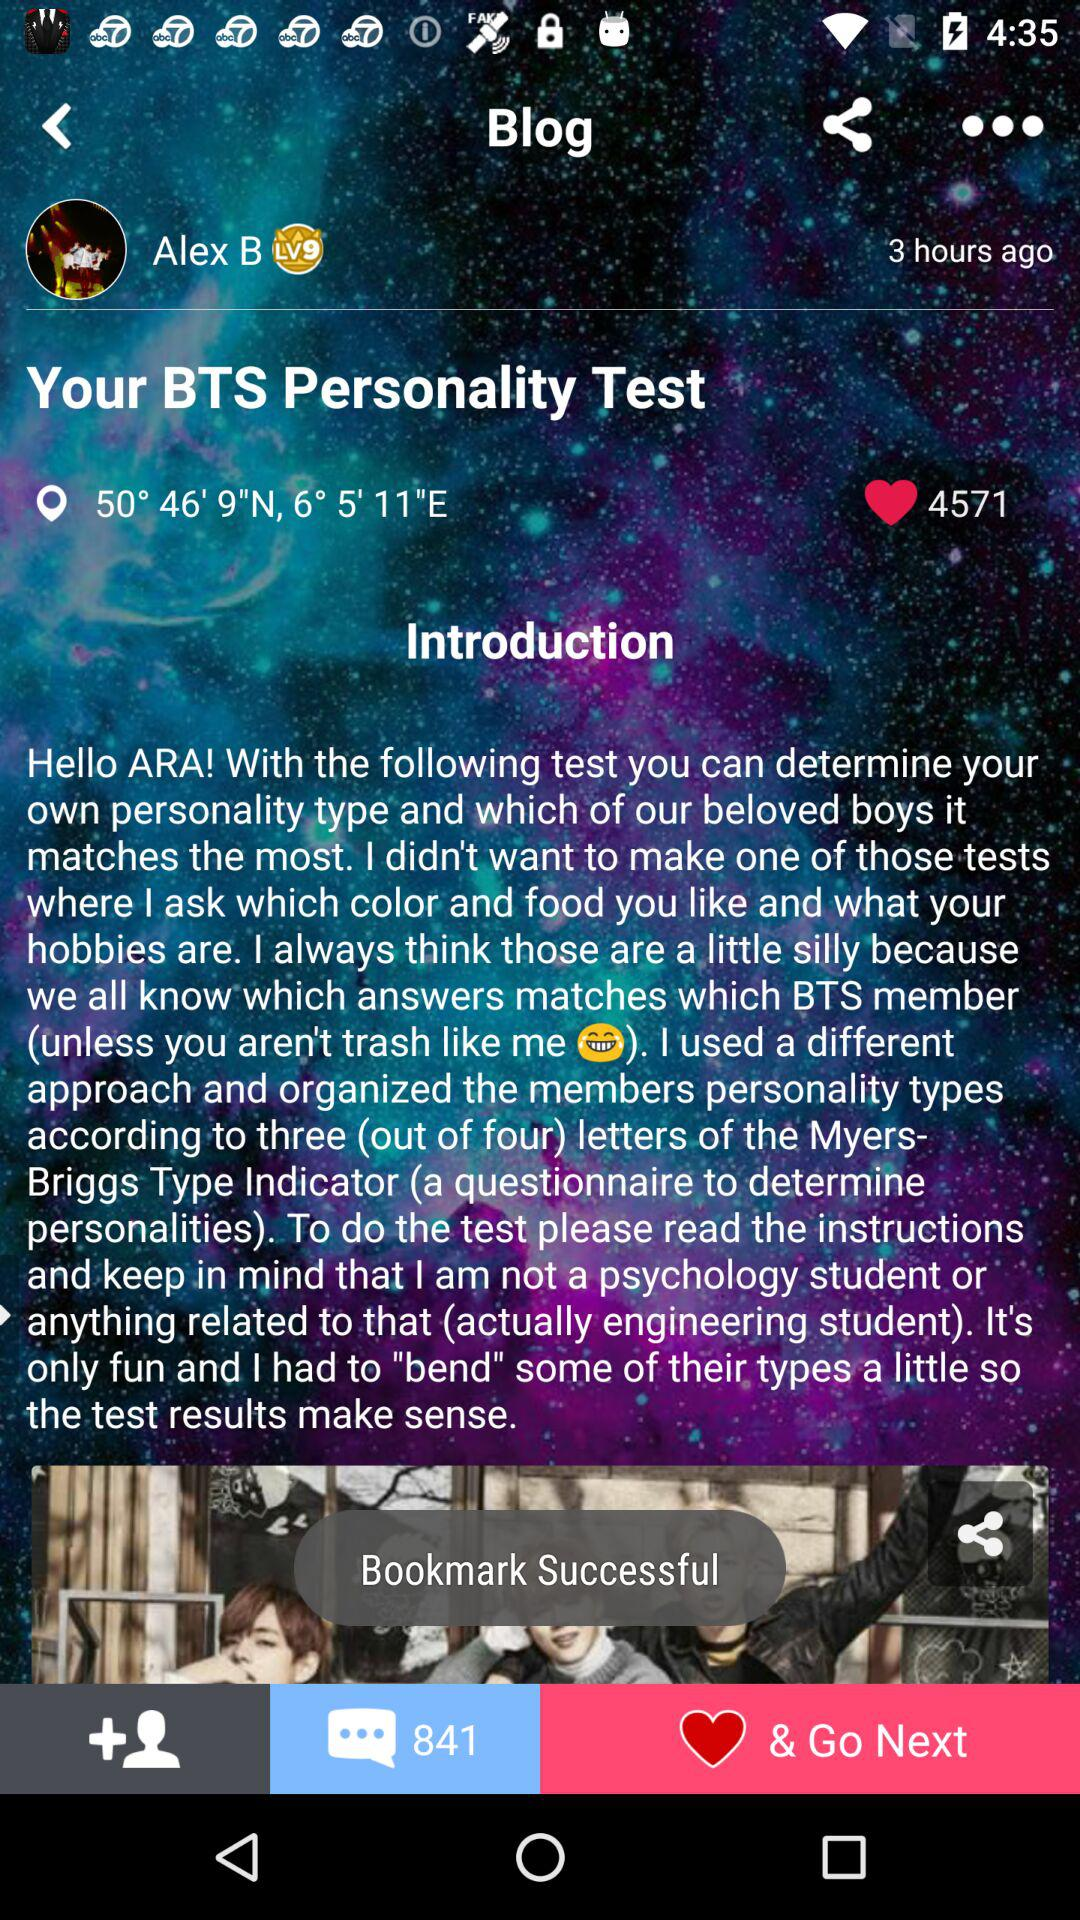How many comments are there on the blog? There are 841 comments on the blog. 